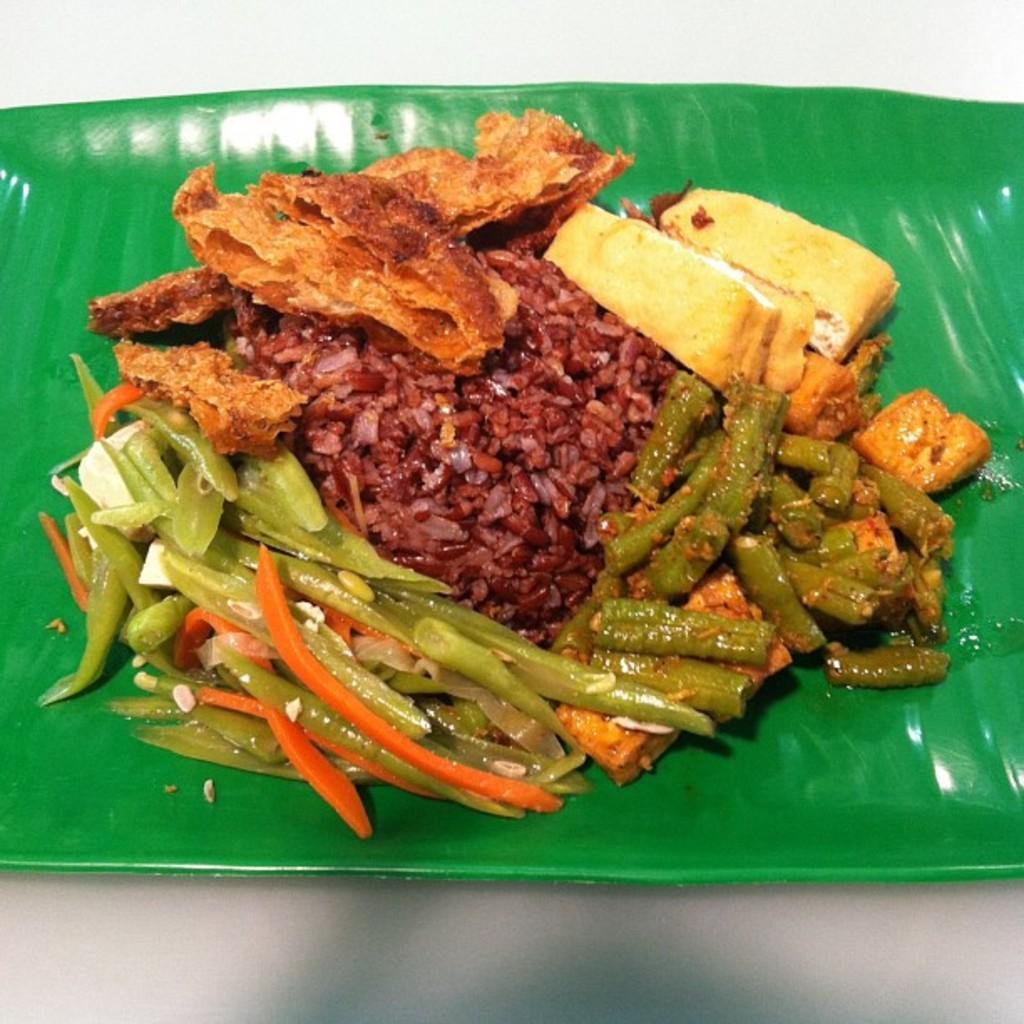In one or two sentences, can you explain what this image depicts? In the image we can see there are food items kept on the banana leaf. 